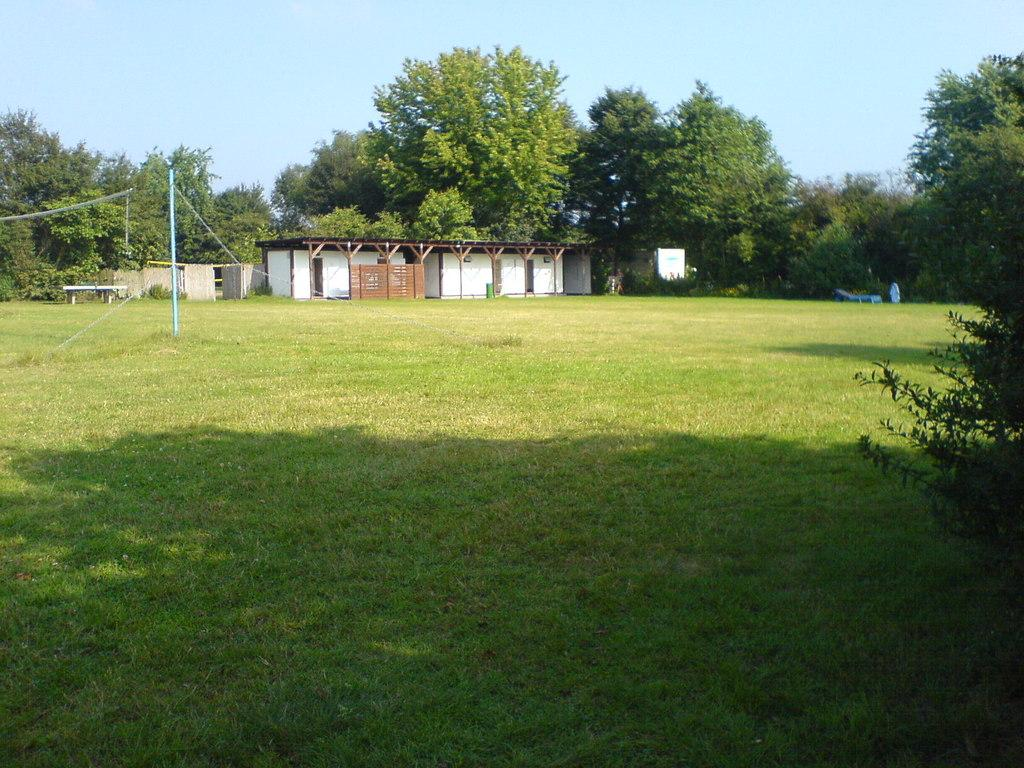What type of vegetation can be seen in the image? There is grass, plants, and trees in the image. What structures are present in the image? There are poles, a bench, and a shed in the image. What can be seen in the background of the image? The sky is visible in the background of the image. Can you see any nests in the trees in the image? There is no mention of nests in the image, so we cannot determine if any are present. What type of bells are hanging from the poles in the image? There are no bells present in the image; only poles, a bench, and a shed are mentioned. 